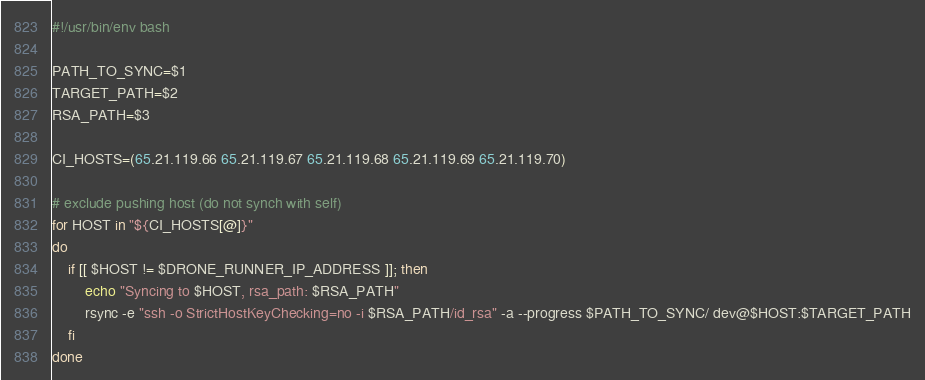Convert code to text. <code><loc_0><loc_0><loc_500><loc_500><_Bash_>#!/usr/bin/env bash

PATH_TO_SYNC=$1
TARGET_PATH=$2
RSA_PATH=$3

CI_HOSTS=(65.21.119.66 65.21.119.67 65.21.119.68 65.21.119.69 65.21.119.70)

# exclude pushing host (do not synch with self) 
for HOST in "${CI_HOSTS[@]}"
do
    if [[ $HOST != $DRONE_RUNNER_IP_ADDRESS ]]; then
        echo "Syncing to $HOST, rsa_path: $RSA_PATH"
        rsync -e "ssh -o StrictHostKeyChecking=no -i $RSA_PATH/id_rsa" -a --progress $PATH_TO_SYNC/ dev@$HOST:$TARGET_PATH
    fi
done
</code> 